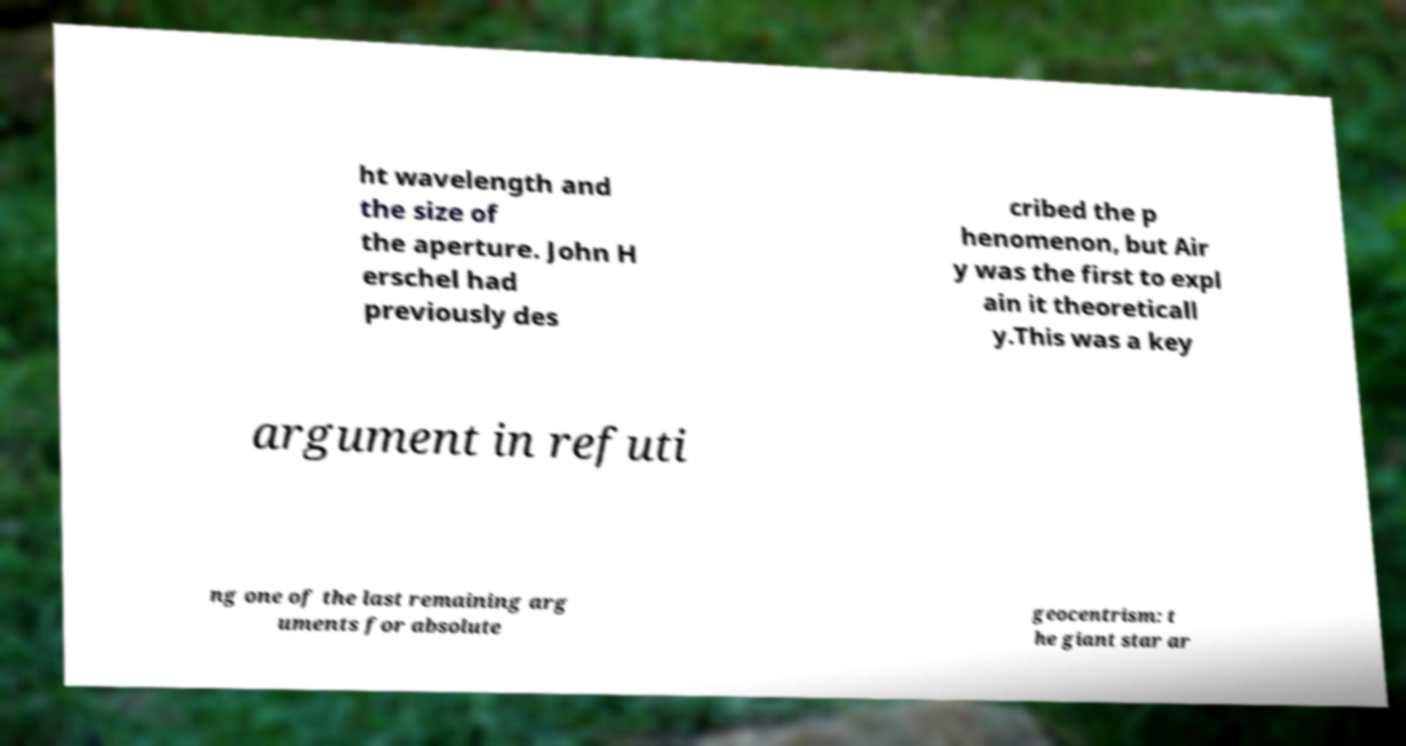Can you read and provide the text displayed in the image?This photo seems to have some interesting text. Can you extract and type it out for me? ht wavelength and the size of the aperture. John H erschel had previously des cribed the p henomenon, but Air y was the first to expl ain it theoreticall y.This was a key argument in refuti ng one of the last remaining arg uments for absolute geocentrism: t he giant star ar 